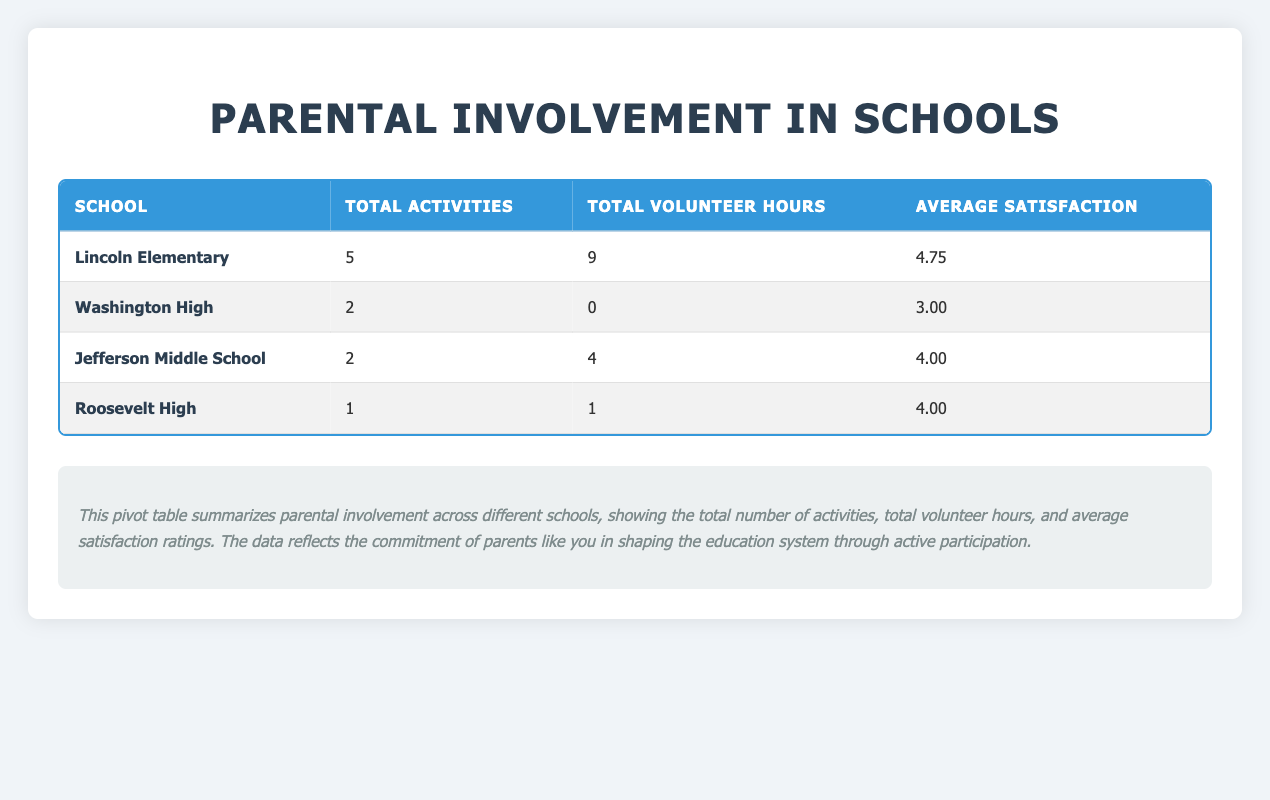What is the total number of activities in Lincoln Elementary? In the table, Lincoln Elementary has 5 entries under the Total Activities column. Thus, its total number of activities is 5.
Answer: 5 What school has the highest average satisfaction rating? By looking at the Average Satisfaction column, Lincoln Elementary has an average satisfaction of 4.75, which is the highest compared to the other schools listed.
Answer: Lincoln Elementary How many total volunteer hours were recorded at Washington High? From the Total Volunteer Hours column, Washington High has 0 volunteer hours recorded, as noted in its row.
Answer: 0 Did any parent not participate in a PTA Meeting at Lincoln Elementary? Yes, Michael Brown did not attend the PTA Meeting, as shown in his row where Attendance is marked as "No."
Answer: Yes What is the difference in total volunteer hours between Jefferson Middle School and Roosevelt High? Jefferson Middle School has 4 total volunteer hours, while Roosevelt High has 1. The difference is calculated as 4 - 1 = 3.
Answer: 3 What is the average volunteer hours for parents involved in activities across all schools? The total volunteer hours for all schools can be summarized as: 9 (Lincoln) + 0 (Washington) + 4 (Jefferson) + 1 (Roosevelt) = 14 hours. There are 10 entries, hence the average volunteer hours is 14/10 = 1.4.
Answer: 1.4 Is there any activity type where all parents attended? Yes, for the Parent-Teacher Conference at Roosevelt High, every parent mentioned attended, as indicated in its row.
Answer: Yes Which school had the least number of total activities? Roosevelt High had the least number of total activities, with only 1 listed in the Total Activities column.
Answer: Roosevelt High What proportion of parents were actively involved (by attending) in Lincoln Elementary's activities? Lincoln Elementary had 5 activities listed, all attended by parents except for Michael Brown's entry. This gives it 4 actively involved parents out of 5, making the proportion 4/5 = 0.8 or 80%.
Answer: 80% 